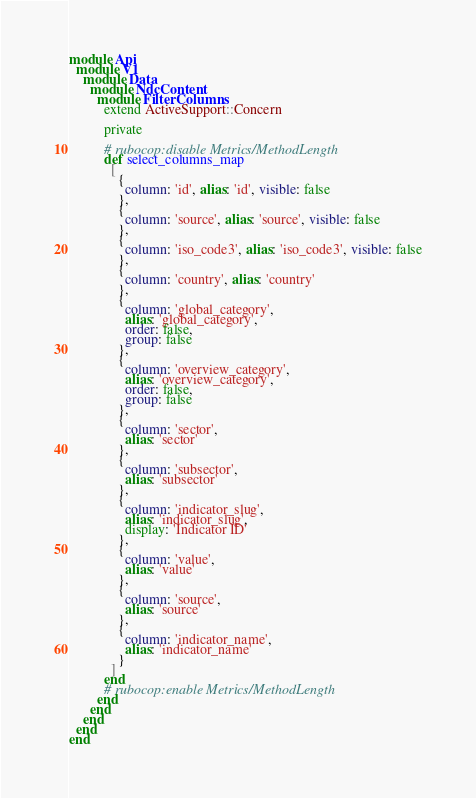Convert code to text. <code><loc_0><loc_0><loc_500><loc_500><_Ruby_>module Api
  module V1
    module Data
      module NdcContent
        module FilterColumns
          extend ActiveSupport::Concern

          private

          # rubocop:disable Metrics/MethodLength
          def select_columns_map
            [
              {
                column: 'id', alias: 'id', visible: false
              },
              {
                column: 'source', alias: 'source', visible: false
              },
              {
                column: 'iso_code3', alias: 'iso_code3', visible: false
              },
              {
                column: 'country', alias: 'country'
              },
              {
                column: 'global_category',
                alias: 'global_category',
                order: false,
                group: false
              },
              {
                column: 'overview_category',
                alias: 'overview_category',
                order: false,
                group: false
              },
              {
                column: 'sector',
                alias: 'sector'
              },
              {
                column: 'subsector',
                alias: 'subsector'
              },
              {
                column: 'indicator_slug',
                alias: 'indicator_slug',
                display: 'Indicator ID'
              },
              {
                column: 'value',
                alias: 'value'
              },
              {
                column: 'source',
                alias: 'source'
              },
              {
                column: 'indicator_name',
                alias: 'indicator_name'
              }
            ]
          end
          # rubocop:enable Metrics/MethodLength
        end
      end
    end
  end
end
</code> 